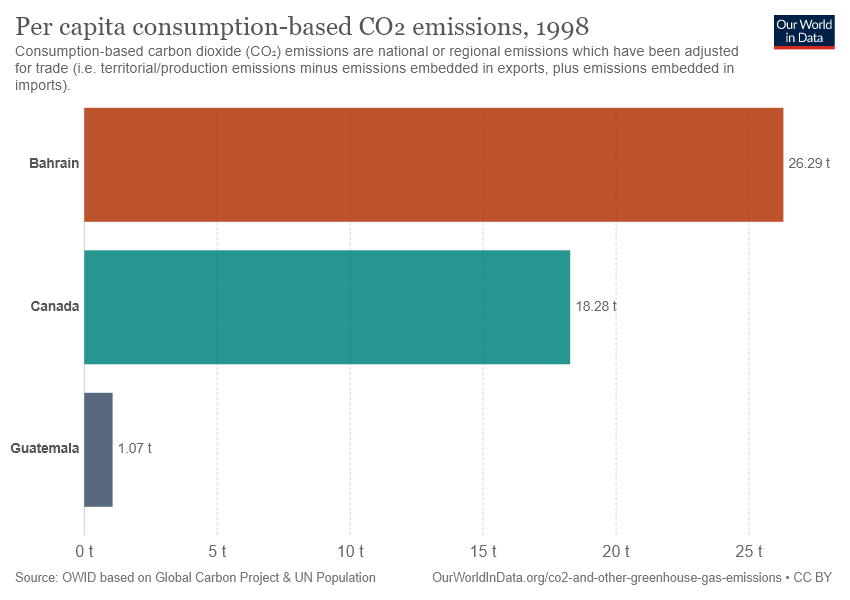Indicate a few pertinent items in this graphic. The average per capita consumption-based CO2 emissions of the three countries in the graph are greater than 14 tons. The per capita consumption-based CO2 emissions in Bahrain are 26.29. 